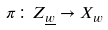<formula> <loc_0><loc_0><loc_500><loc_500>\pi \colon Z _ { \underline { w } } \rightarrow X _ { w }</formula> 